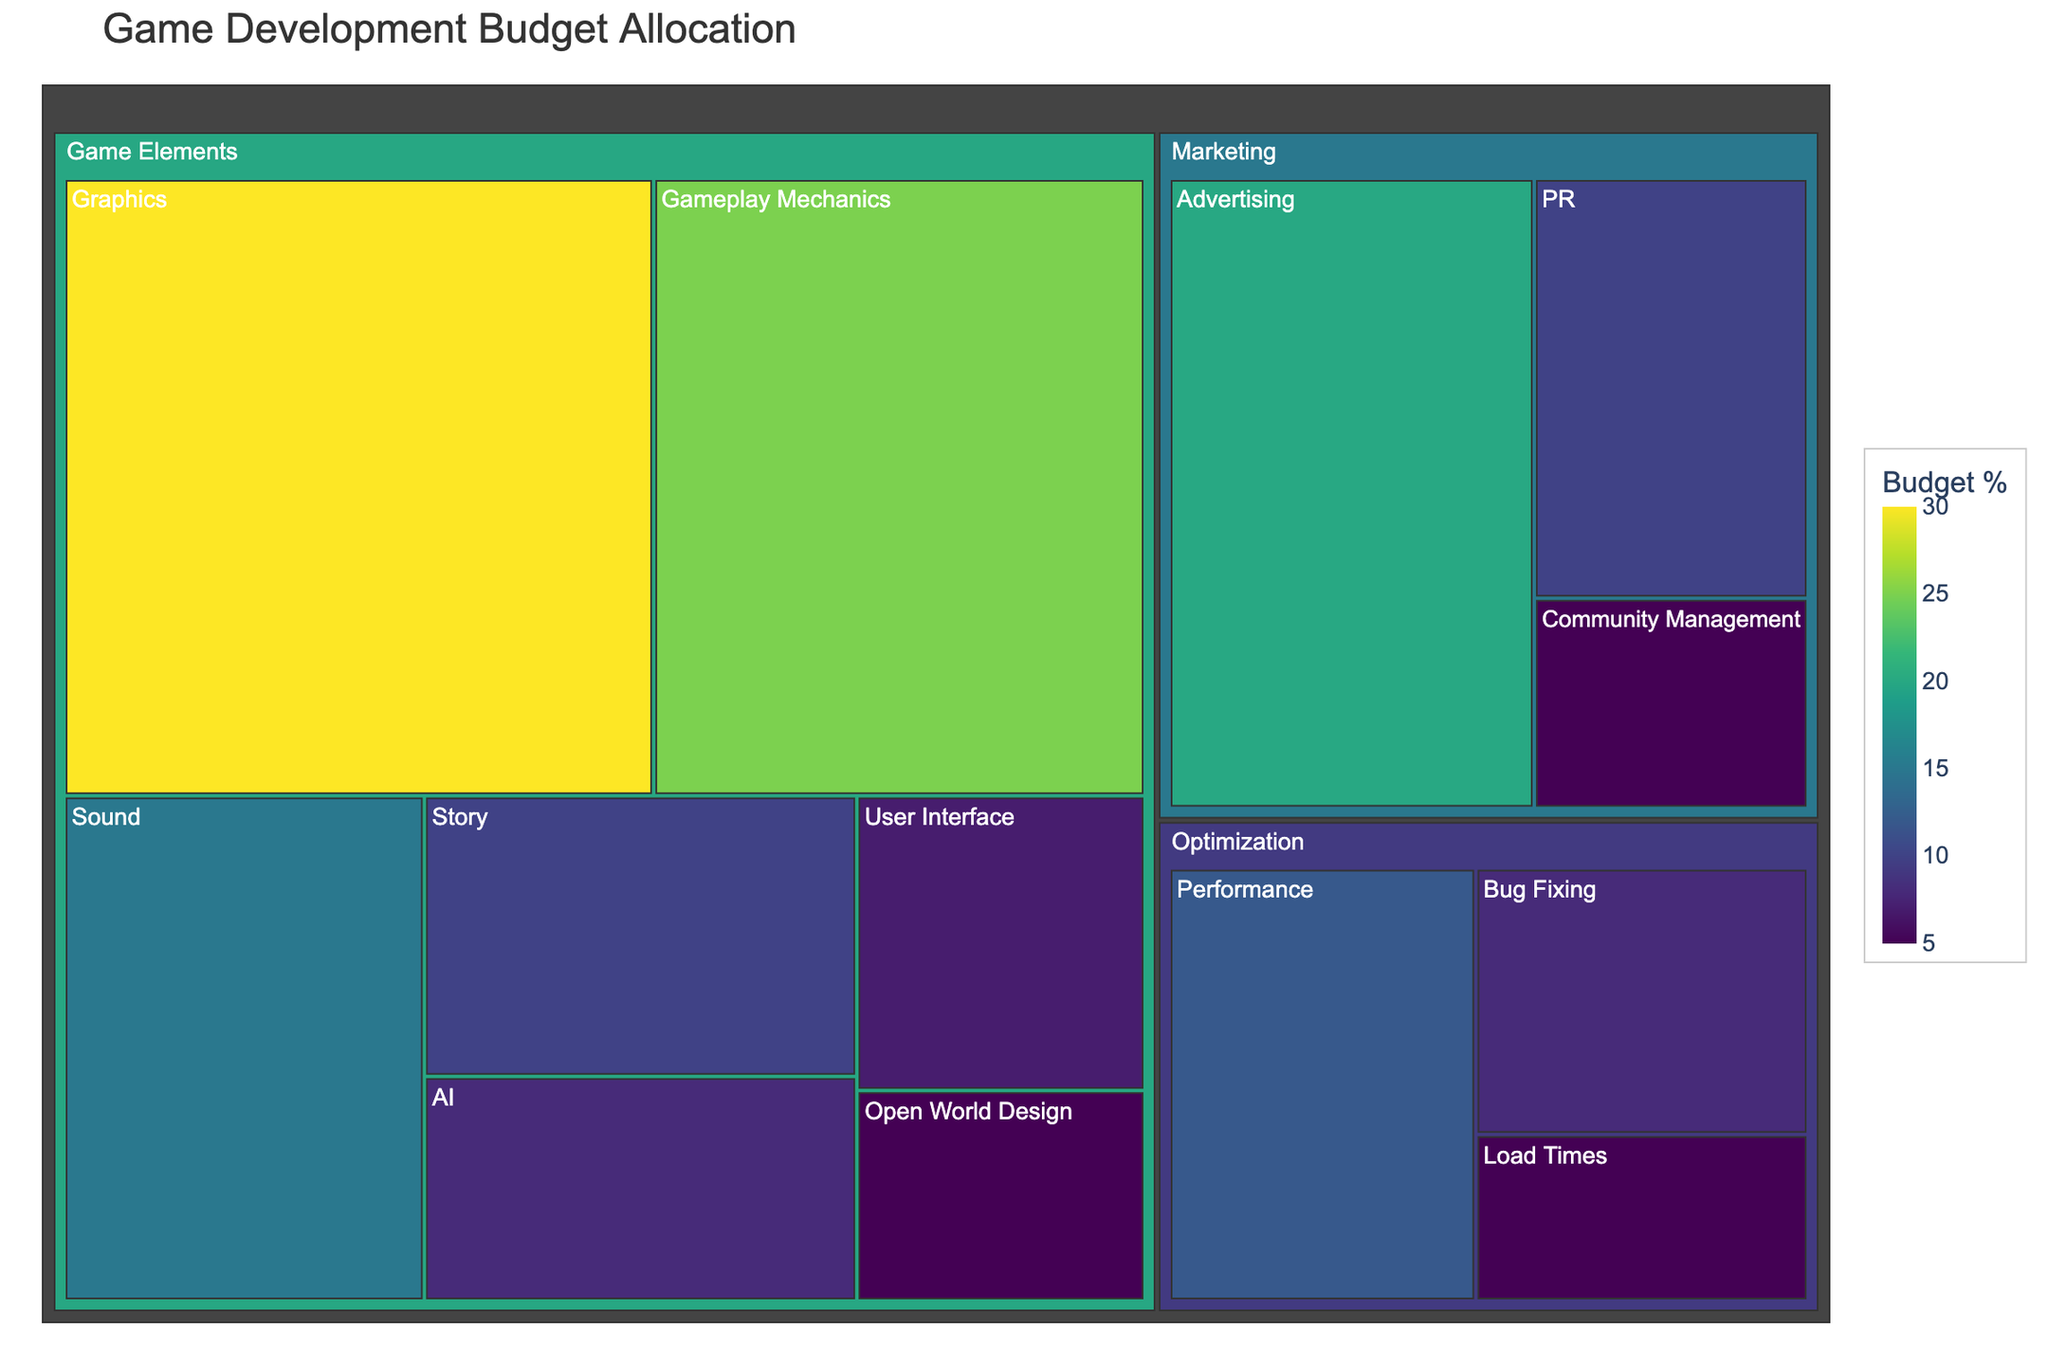What's the title of the treemap? The title of a treemap is typically found at the very top of the visual representation. In this case, it is stated clearly in the code.
Answer: Game Development Budget Allocation Which subcategory has the highest budget allocation under Game Elements? To determine the highest budget allocation, look at the values for each subcategory under Game Elements and identify the one with the largest value.
Answer: Graphics What is the total budget allocation for the subcategories under Optimization? Add the values of the subcategories under Optimization: Performance (12), Bug Fixing (8), and Load Times (5). The sum is 12 + 8 + 5.
Answer: 25 Which has a higher budget allocation: Marketing or Game Elements? Sum the values for each subcategory under Marketing (20+10+5) and Game Elements (30+15+25+10+8+7+5), then compare the totals.
Answer: Game Elements Is there a significant budget allocation for Open World Design? To determine if an allocation is significant, compare it to other subcategories. Open World Design has a budget allocation of 5, which is relatively low compared to others like Graphics and Gameplay Mechanics.
Answer: No Which category has the smallest budget allocation? Compare the total values assigned to each top-level category. Community Management under Marketing is the smallest with a value of 5.
Answer: Community Management What's the combined budget allocation for Sound and AI under Game Elements? Add the values for Sound (15) and AI (8) under the Game Elements category. The sum is 15 + 8.
Answer: 23 Does Advertising have a higher budget allocation than Game Story Development? Compare the value for Advertising under Marketing (20) with Story under Game Elements (10).
Answer: Yes List all subcategories with a budget allocation less than 10. Identify subcategories with a value less than 10. These include AI (8), User Interface (7), Open World Design (5), Bug Fixing (8), Load Times (5), and Community Management (5).
Answer: AI, User Interface, Open World Design, Bug Fixing, Load Times, Community Management What's the percentage difference between the budget allocation for Graphics and Story under Game Elements? Subtract the value for Story (10) from Graphics (30) to get the difference (20). Then divide the difference by the value for Story and multiply by 100 to get the percentage: (20/10) * 100.
Answer: 200% 